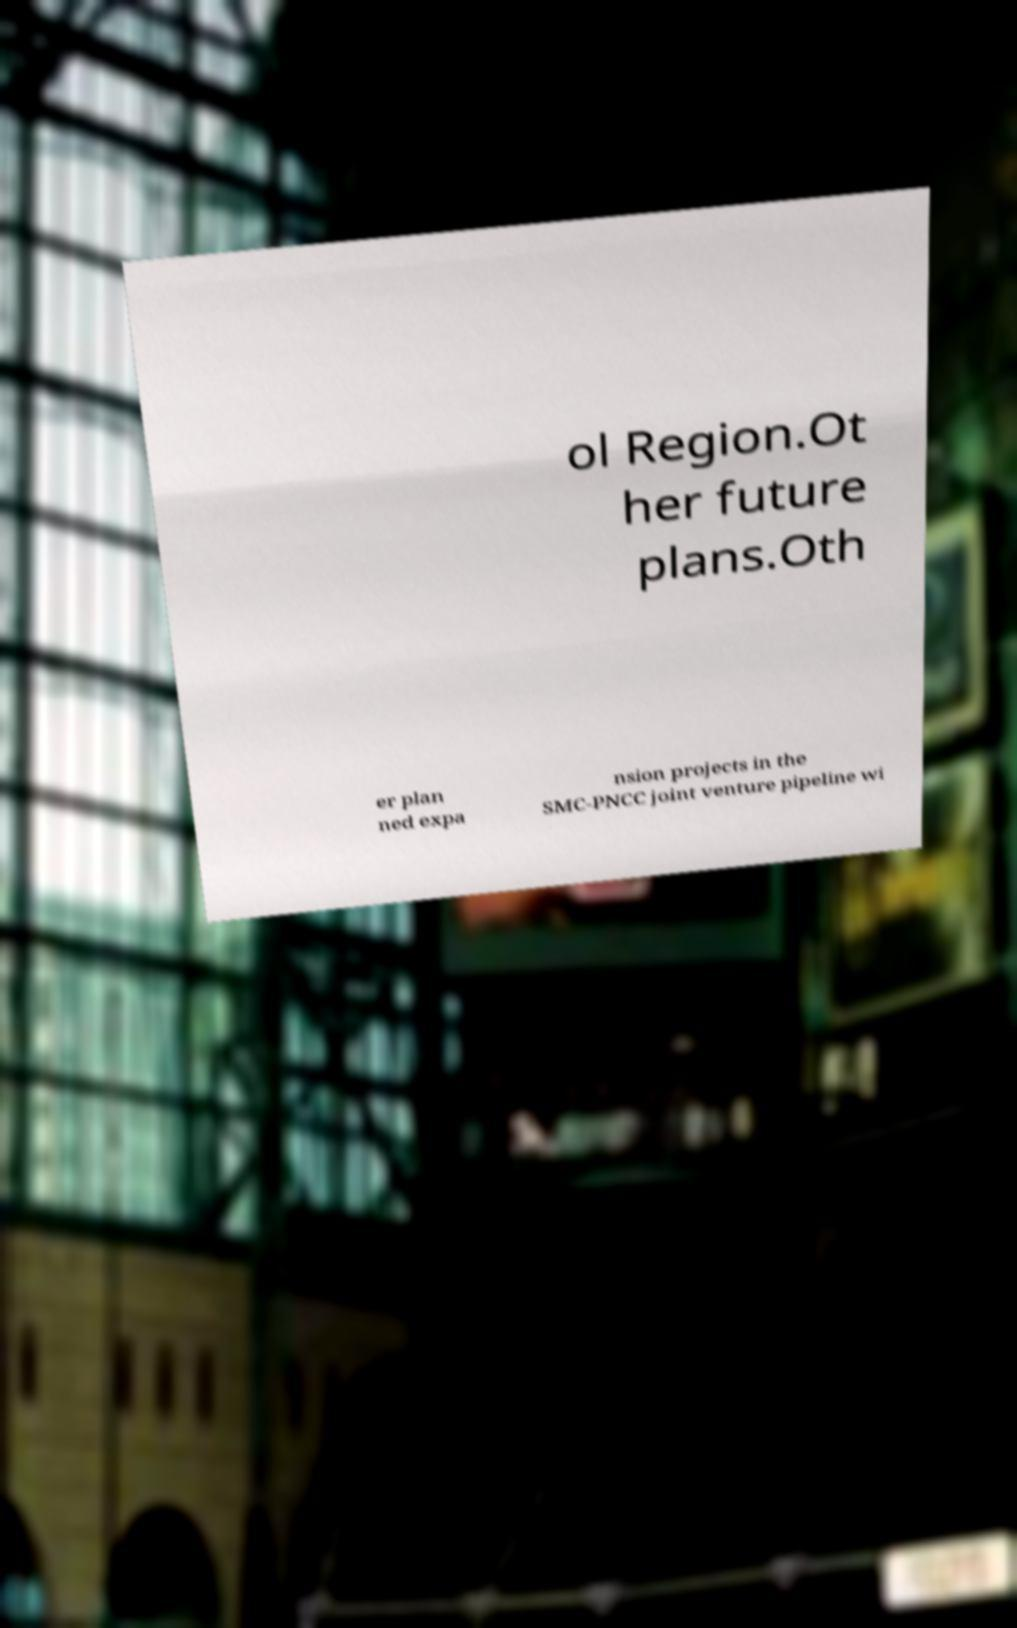Please read and relay the text visible in this image. What does it say? ol Region.Ot her future plans.Oth er plan ned expa nsion projects in the SMC-PNCC joint venture pipeline wi 